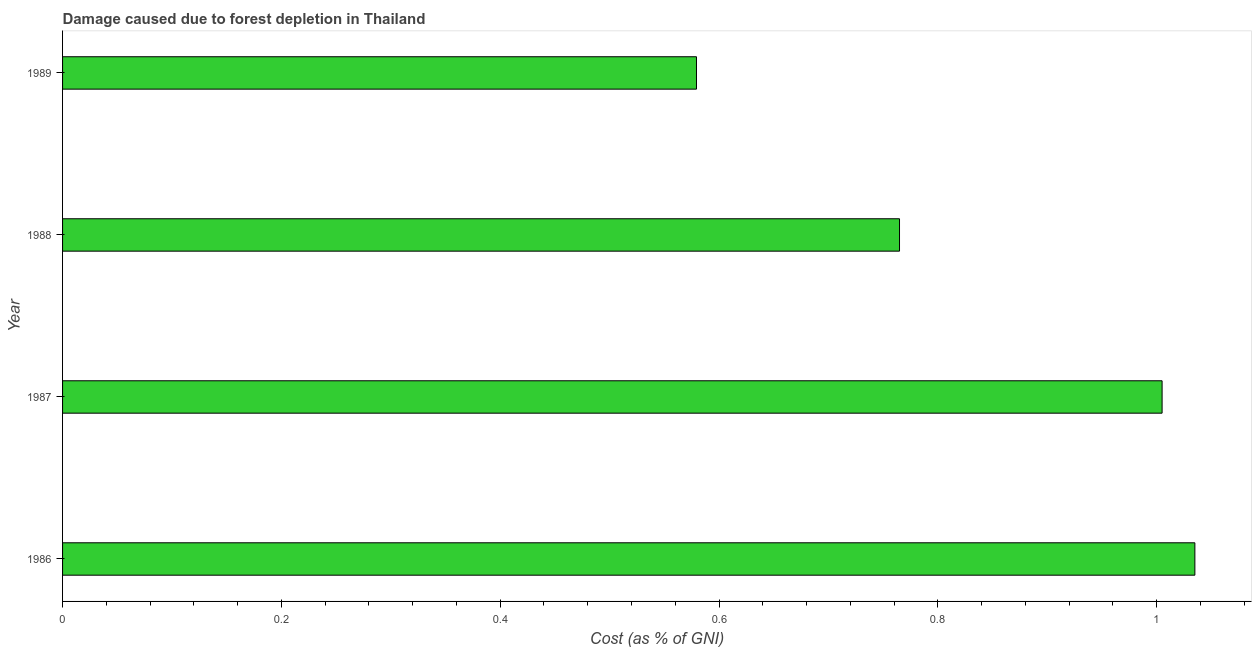Does the graph contain any zero values?
Ensure brevity in your answer.  No. What is the title of the graph?
Keep it short and to the point. Damage caused due to forest depletion in Thailand. What is the label or title of the X-axis?
Make the answer very short. Cost (as % of GNI). What is the label or title of the Y-axis?
Offer a very short reply. Year. What is the damage caused due to forest depletion in 1988?
Keep it short and to the point. 0.76. Across all years, what is the maximum damage caused due to forest depletion?
Keep it short and to the point. 1.03. Across all years, what is the minimum damage caused due to forest depletion?
Your answer should be very brief. 0.58. In which year was the damage caused due to forest depletion maximum?
Keep it short and to the point. 1986. What is the sum of the damage caused due to forest depletion?
Provide a succinct answer. 3.38. What is the difference between the damage caused due to forest depletion in 1986 and 1988?
Your response must be concise. 0.27. What is the average damage caused due to forest depletion per year?
Your answer should be very brief. 0.85. What is the median damage caused due to forest depletion?
Your answer should be very brief. 0.88. In how many years, is the damage caused due to forest depletion greater than 0.96 %?
Offer a very short reply. 2. What is the ratio of the damage caused due to forest depletion in 1986 to that in 1989?
Give a very brief answer. 1.79. Is the damage caused due to forest depletion in 1987 less than that in 1989?
Your response must be concise. No. What is the difference between the highest and the lowest damage caused due to forest depletion?
Give a very brief answer. 0.46. In how many years, is the damage caused due to forest depletion greater than the average damage caused due to forest depletion taken over all years?
Keep it short and to the point. 2. Are all the bars in the graph horizontal?
Your answer should be very brief. Yes. What is the Cost (as % of GNI) of 1986?
Your answer should be compact. 1.03. What is the Cost (as % of GNI) of 1987?
Keep it short and to the point. 1. What is the Cost (as % of GNI) in 1988?
Offer a terse response. 0.76. What is the Cost (as % of GNI) in 1989?
Offer a very short reply. 0.58. What is the difference between the Cost (as % of GNI) in 1986 and 1987?
Offer a terse response. 0.03. What is the difference between the Cost (as % of GNI) in 1986 and 1988?
Offer a very short reply. 0.27. What is the difference between the Cost (as % of GNI) in 1986 and 1989?
Your answer should be very brief. 0.46. What is the difference between the Cost (as % of GNI) in 1987 and 1988?
Provide a short and direct response. 0.24. What is the difference between the Cost (as % of GNI) in 1987 and 1989?
Keep it short and to the point. 0.43. What is the difference between the Cost (as % of GNI) in 1988 and 1989?
Keep it short and to the point. 0.19. What is the ratio of the Cost (as % of GNI) in 1986 to that in 1987?
Make the answer very short. 1.03. What is the ratio of the Cost (as % of GNI) in 1986 to that in 1988?
Your response must be concise. 1.35. What is the ratio of the Cost (as % of GNI) in 1986 to that in 1989?
Provide a short and direct response. 1.79. What is the ratio of the Cost (as % of GNI) in 1987 to that in 1988?
Provide a succinct answer. 1.31. What is the ratio of the Cost (as % of GNI) in 1987 to that in 1989?
Your answer should be very brief. 1.74. What is the ratio of the Cost (as % of GNI) in 1988 to that in 1989?
Provide a short and direct response. 1.32. 